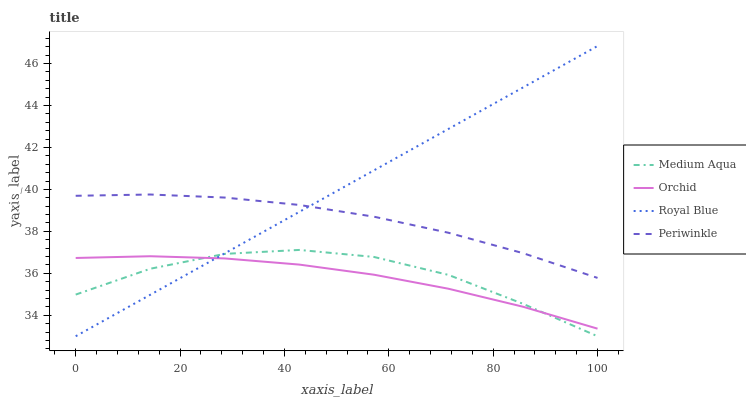Does Periwinkle have the minimum area under the curve?
Answer yes or no. No. Does Periwinkle have the maximum area under the curve?
Answer yes or no. No. Is Periwinkle the smoothest?
Answer yes or no. No. Is Periwinkle the roughest?
Answer yes or no. No. Does Periwinkle have the lowest value?
Answer yes or no. No. Does Periwinkle have the highest value?
Answer yes or no. No. Is Orchid less than Periwinkle?
Answer yes or no. Yes. Is Periwinkle greater than Orchid?
Answer yes or no. Yes. Does Orchid intersect Periwinkle?
Answer yes or no. No. 